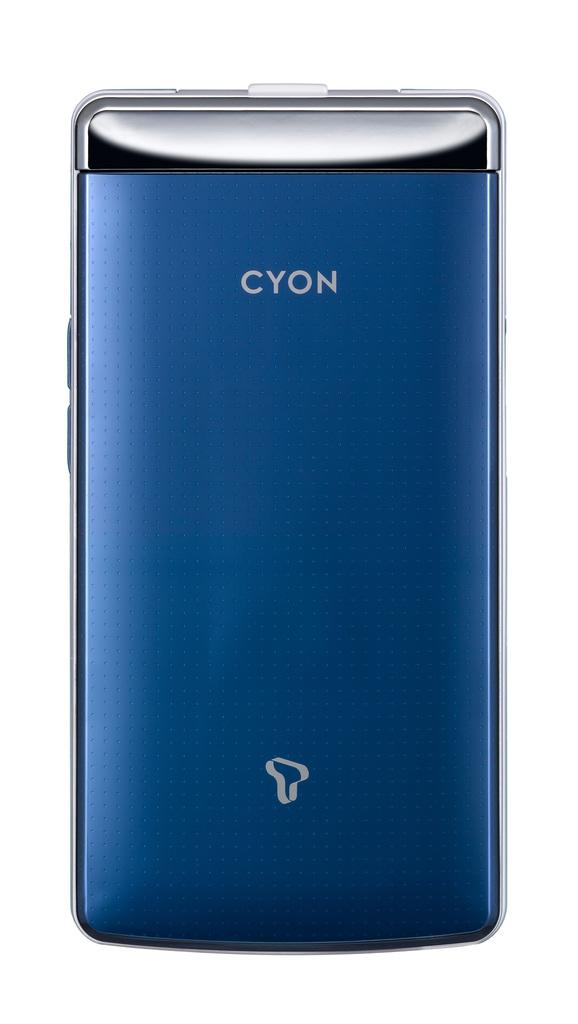What company makes the phone case?
Give a very brief answer. Cyon. What brand phone is this?
Keep it short and to the point. Cyon. 